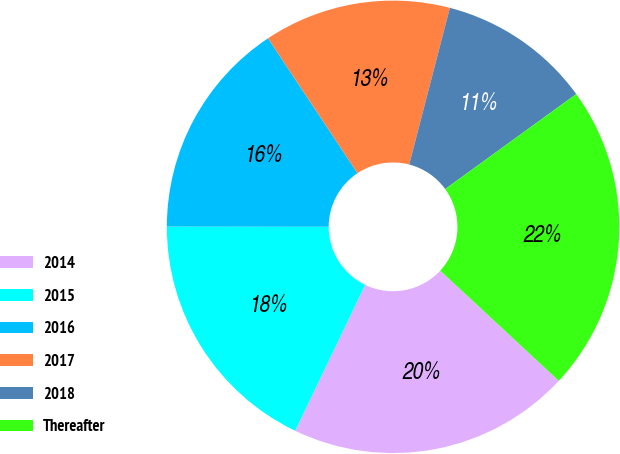<chart> <loc_0><loc_0><loc_500><loc_500><pie_chart><fcel>2014<fcel>2015<fcel>2016<fcel>2017<fcel>2018<fcel>Thereafter<nl><fcel>20.2%<fcel>17.9%<fcel>15.66%<fcel>13.36%<fcel>10.98%<fcel>21.9%<nl></chart> 